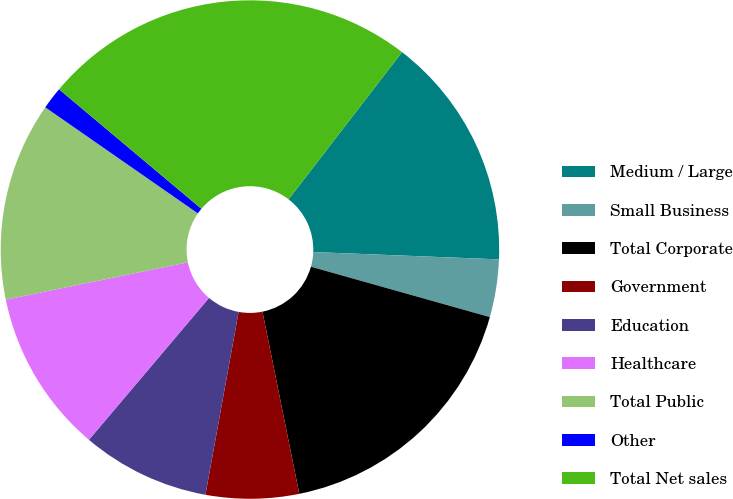Convert chart to OTSL. <chart><loc_0><loc_0><loc_500><loc_500><pie_chart><fcel>Medium / Large<fcel>Small Business<fcel>Total Corporate<fcel>Government<fcel>Education<fcel>Healthcare<fcel>Total Public<fcel>Other<fcel>Total Net sales<nl><fcel>15.18%<fcel>3.74%<fcel>17.46%<fcel>6.03%<fcel>8.32%<fcel>10.6%<fcel>12.89%<fcel>1.45%<fcel>24.33%<nl></chart> 